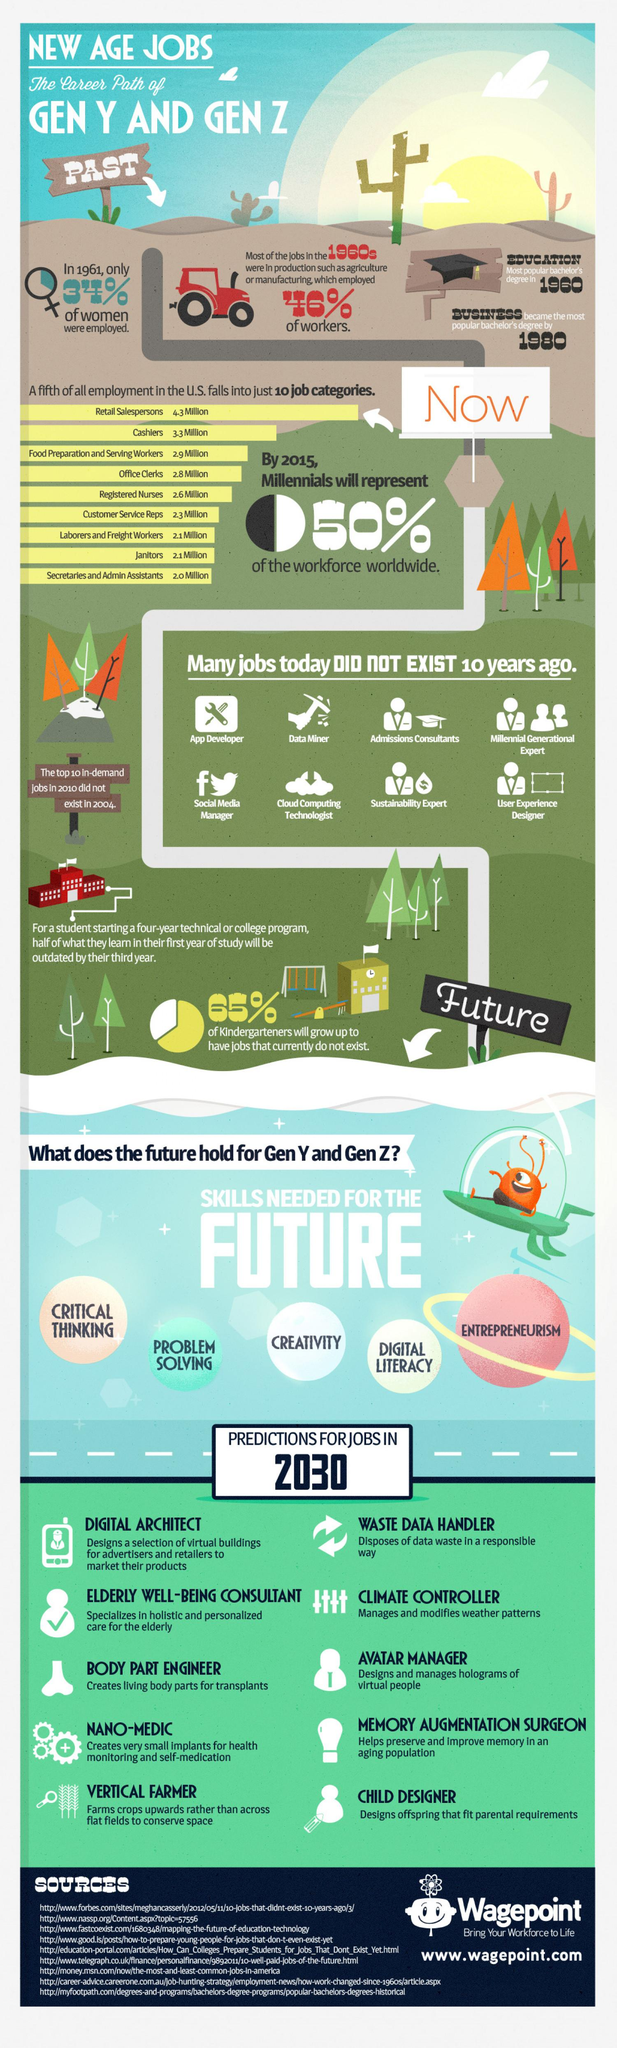Indicate a few pertinent items in this graphic. In 1980, business was the most sought-after bachelor's degree. In the 1960s, the majority of jobs were concentrated in either the agriculture or manufacturing sectors. The job title for a person who designs holograms of virtual people is likely "Avatar Manager," as this position involves overseeing the creation and management of virtual avatars. The second highest number of people work in the present job category in the United States. In 1960, education was the most sought-after bachelor's degree. 